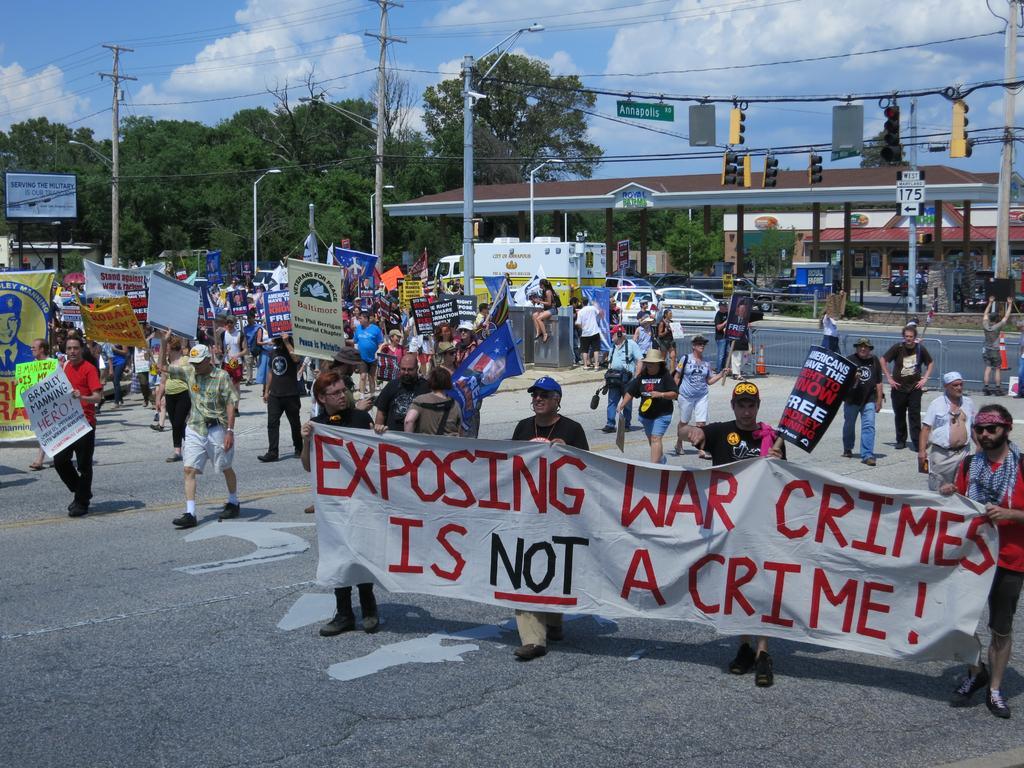How would you summarize this image in a sentence or two? In this picture there are people, among them few people holding banners and we can see poles, wires, traffic signals, lights, wires and boards. In the background of the image we can see shed, houses, vehicles on the road, trees and sky with clouds. 